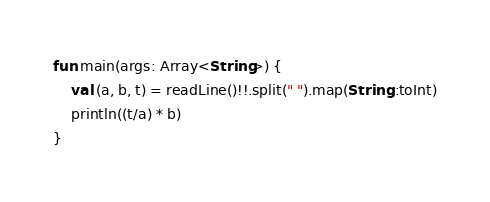<code> <loc_0><loc_0><loc_500><loc_500><_Kotlin_>fun main(args: Array<String>) {
    val (a, b, t) = readLine()!!.split(" ").map(String::toInt)
    println((t/a) * b)
}</code> 